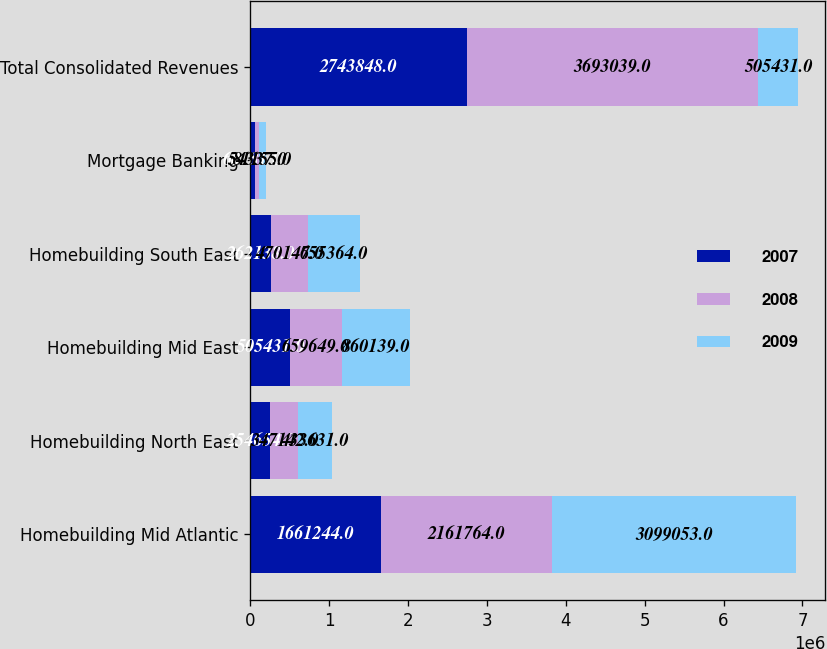<chart> <loc_0><loc_0><loc_500><loc_500><stacked_bar_chart><ecel><fcel>Homebuilding Mid Atlantic<fcel>Homebuilding North East<fcel>Homebuilding Mid East<fcel>Homebuilding South East<fcel>Mortgage Banking<fcel>Total Consolidated Revenues<nl><fcel>2007<fcel>1.66124e+06<fcel>254654<fcel>505431<fcel>262138<fcel>60381<fcel>2.74385e+06<nl><fcel>2008<fcel>2.16176e+06<fcel>347142<fcel>659649<fcel>470147<fcel>54337<fcel>3.69304e+06<nl><fcel>2009<fcel>3.09905e+06<fcel>433631<fcel>860139<fcel>655364<fcel>81155<fcel>505431<nl></chart> 